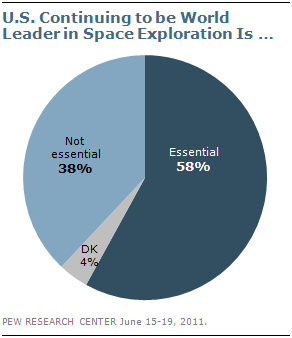List a handful of essential elements in this visual. The highest value in the Pie chart is represented by dark blue. It is not essential that the sum of the two least values of a segment is greater than the essential value. 